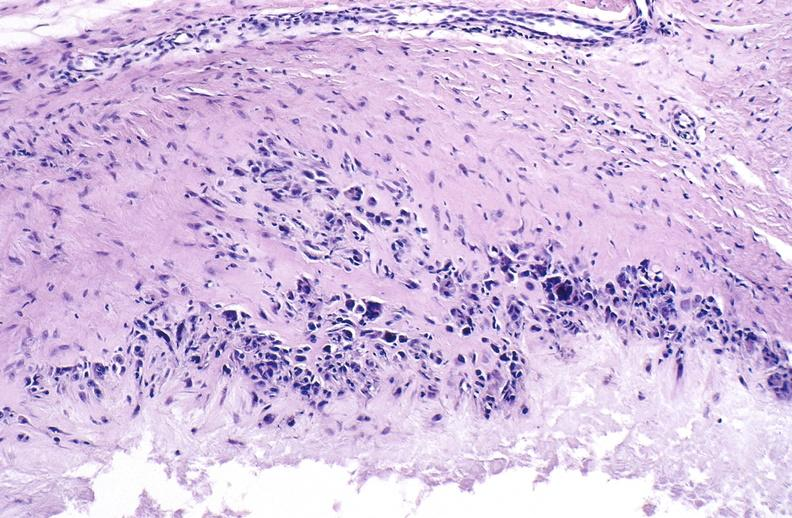s external view several capsule lacerations present?
Answer the question using a single word or phrase. No 